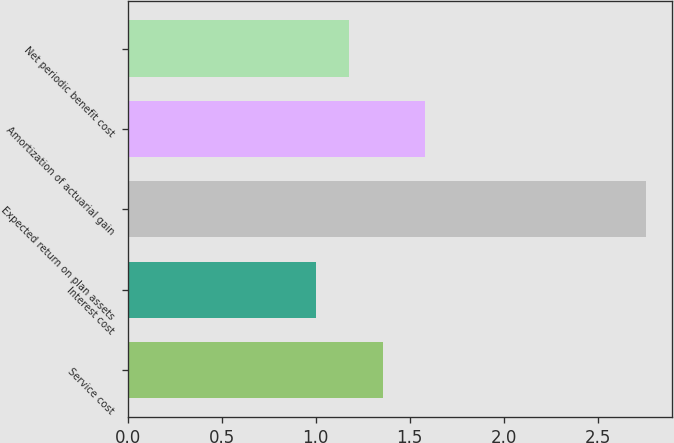<chart> <loc_0><loc_0><loc_500><loc_500><bar_chart><fcel>Service cost<fcel>Interest cost<fcel>Expected return on plan assets<fcel>Amortization of actuarial gain<fcel>Net periodic benefit cost<nl><fcel>1.36<fcel>1<fcel>2.76<fcel>1.58<fcel>1.18<nl></chart> 